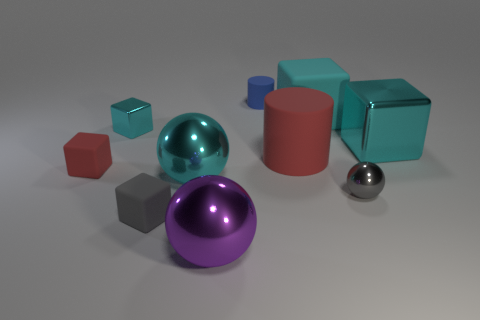What number of green things are either big cylinders or small metallic things?
Your answer should be compact. 0. How many other objects are there of the same color as the big matte cube?
Ensure brevity in your answer.  3. Are there fewer tiny objects that are left of the gray rubber thing than cyan cubes?
Ensure brevity in your answer.  Yes. The cylinder behind the red matte thing that is on the right side of the big ball that is behind the gray sphere is what color?
Your answer should be compact. Blue. The other object that is the same shape as the tiny blue thing is what size?
Keep it short and to the point. Large. Is the number of big cyan things behind the red block less than the number of gray cubes that are to the right of the tiny gray ball?
Offer a terse response. No. There is a large metal object that is both behind the small gray matte cube and on the left side of the cyan matte thing; what shape is it?
Offer a very short reply. Sphere. There is a blue thing that is made of the same material as the large red cylinder; what is its size?
Your response must be concise. Small. Does the big rubber cylinder have the same color as the tiny rubber cube behind the gray metal object?
Give a very brief answer. Yes. What is the cube that is both behind the large rubber cylinder and on the left side of the large red rubber thing made of?
Provide a short and direct response. Metal. 